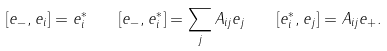<formula> <loc_0><loc_0><loc_500><loc_500>[ e _ { - } , e _ { i } ] = e _ { i } ^ { * } \quad [ e _ { - } , e _ { i } ^ { * } ] = \sum _ { j } A _ { i j } e _ { j } \quad [ e _ { i } ^ { * } , e _ { j } ] = A _ { i j } e _ { + } .</formula> 